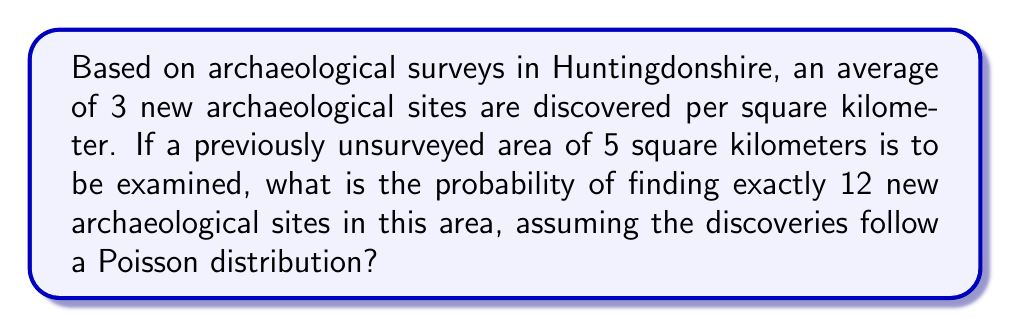Could you help me with this problem? To solve this problem, we'll use the Poisson distribution, which is appropriate for modeling rare events in a fixed area or time interval. Let's follow these steps:

1. Identify the parameters:
   - λ (lambda) = average number of events per unit area * total area
   - λ = 3 sites/km² * 5 km² = 15 sites
   - k (number of events we're interested in) = 12 sites

2. The Poisson probability mass function is:

   $$P(X = k) = \frac{e^{-λ} λ^k}{k!}$$

3. Substitute the values:

   $$P(X = 12) = \frac{e^{-15} 15^{12}}{12!}$$

4. Calculate step by step:
   a) $e^{-15} ≈ 3.0590 × 10^{-7}$
   b) $15^{12} = 129,746,337,890,625$
   c) $12! = 479,001,600$

5. Put it all together:

   $$P(X = 12) = \frac{3.0590 × 10^{-7} × 129,746,337,890,625}{479,001,600}$$

6. Simplify:

   $$P(X = 12) ≈ 0.0825 \text{ or } 8.25\%$$

This means there's approximately an 8.25% chance of finding exactly 12 new archaeological sites in the 5 km² area.
Answer: 0.0825 or 8.25% 